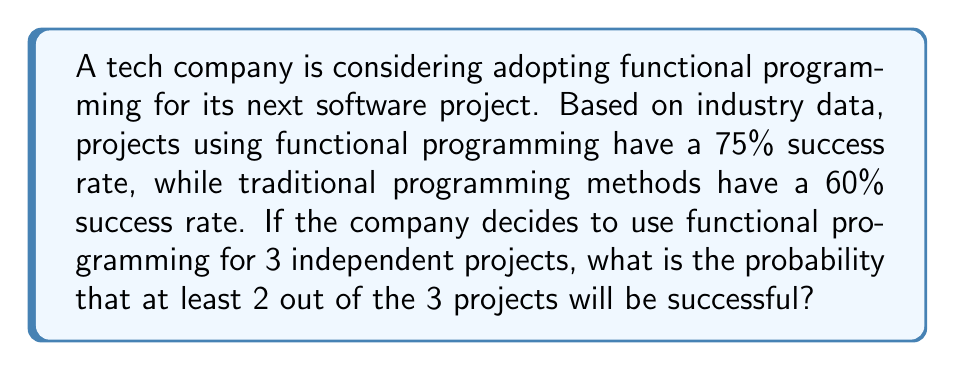Help me with this question. Let's approach this step-by-step:

1) We need to find the probability of at least 2 successes out of 3 independent trials, where each trial has a 75% chance of success.

2) This scenario follows a binomial probability distribution. The probability of exactly $k$ successes in $n$ trials is given by the formula:

   $P(X = k) = \binom{n}{k} p^k (1-p)^{n-k}$

   Where $n$ is the number of trials, $k$ is the number of successes, and $p$ is the probability of success on each trial.

3) We want the probability of 2 or 3 successes out of 3 trials. So we need to calculate:

   $P(X \geq 2) = P(X = 2) + P(X = 3)$

4) Let's calculate each part:

   For 2 successes: $P(X = 2) = \binom{3}{2} (0.75)^2 (0.25)^1$
   
   $= 3 \cdot 0.5625 \cdot 0.25 = 0.421875$

   For 3 successes: $P(X = 3) = \binom{3}{3} (0.75)^3 (0.25)^0$
   
   $= 1 \cdot 0.421875 \cdot 1 = 0.421875$

5) Now we sum these probabilities:

   $P(X \geq 2) = 0.421875 + 0.421875 = 0.84375$

Therefore, the probability of at least 2 out of 3 projects being successful is 0.84375 or 84.375%.
Answer: 0.84375 